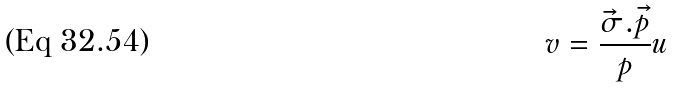<formula> <loc_0><loc_0><loc_500><loc_500>v = \frac { \vec { \sigma } . \vec { p } } { p } u</formula> 